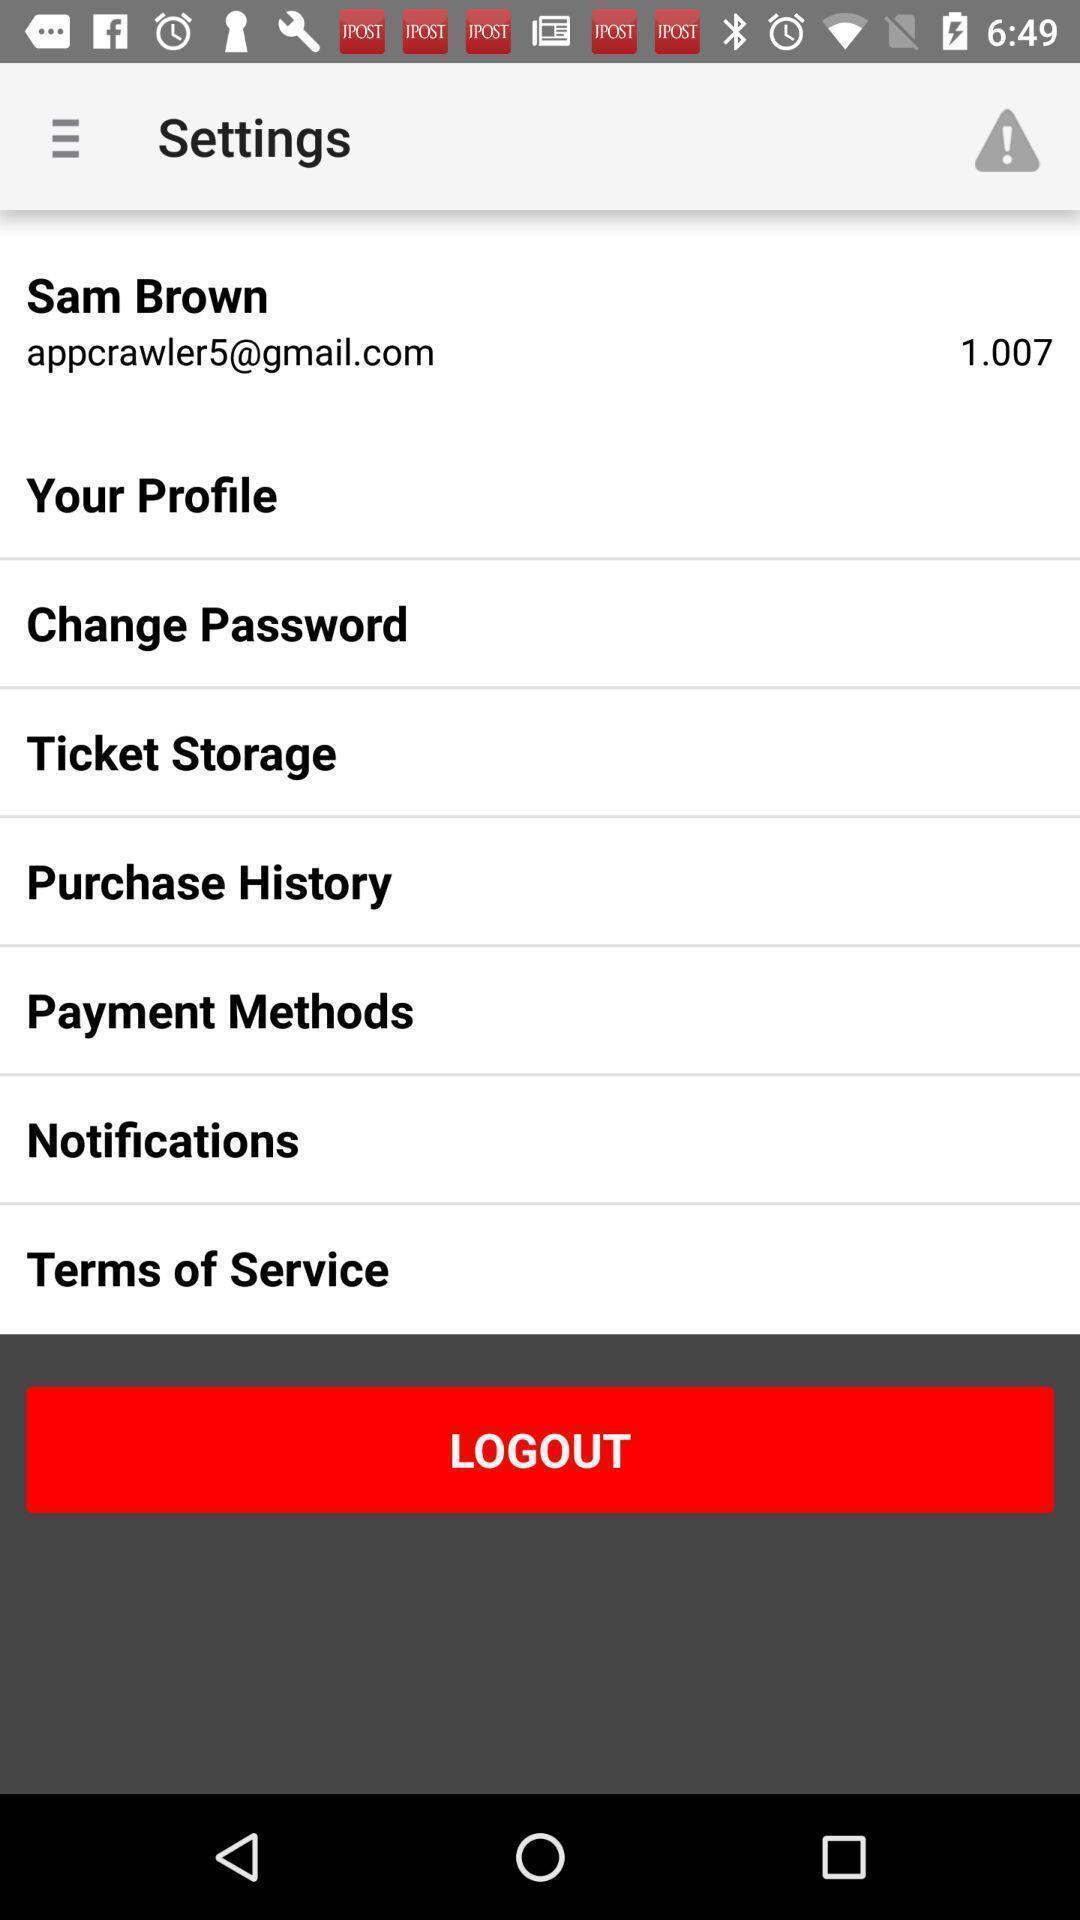Please provide a description for this image. Page shows settings. 